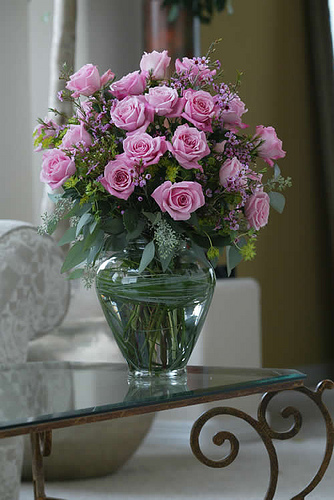<image>What kind of reflection do you see on the floor? I am not sure what kind of reflection is on the floor. It could be a shadow, a couch, a sofa or the sun. What kind of reflection do you see on the floor? I don't know what kind of reflection is seen on the floor. It can be a shadow or none. 